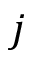Convert formula to latex. <formula><loc_0><loc_0><loc_500><loc_500>j</formula> 